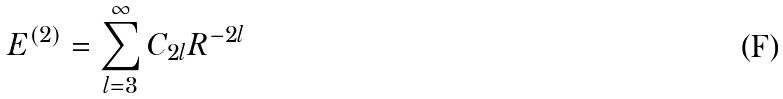<formula> <loc_0><loc_0><loc_500><loc_500>E ^ { ( 2 ) } = \sum _ { l = 3 } ^ { \infty } C _ { 2 l } R ^ { - 2 l }</formula> 